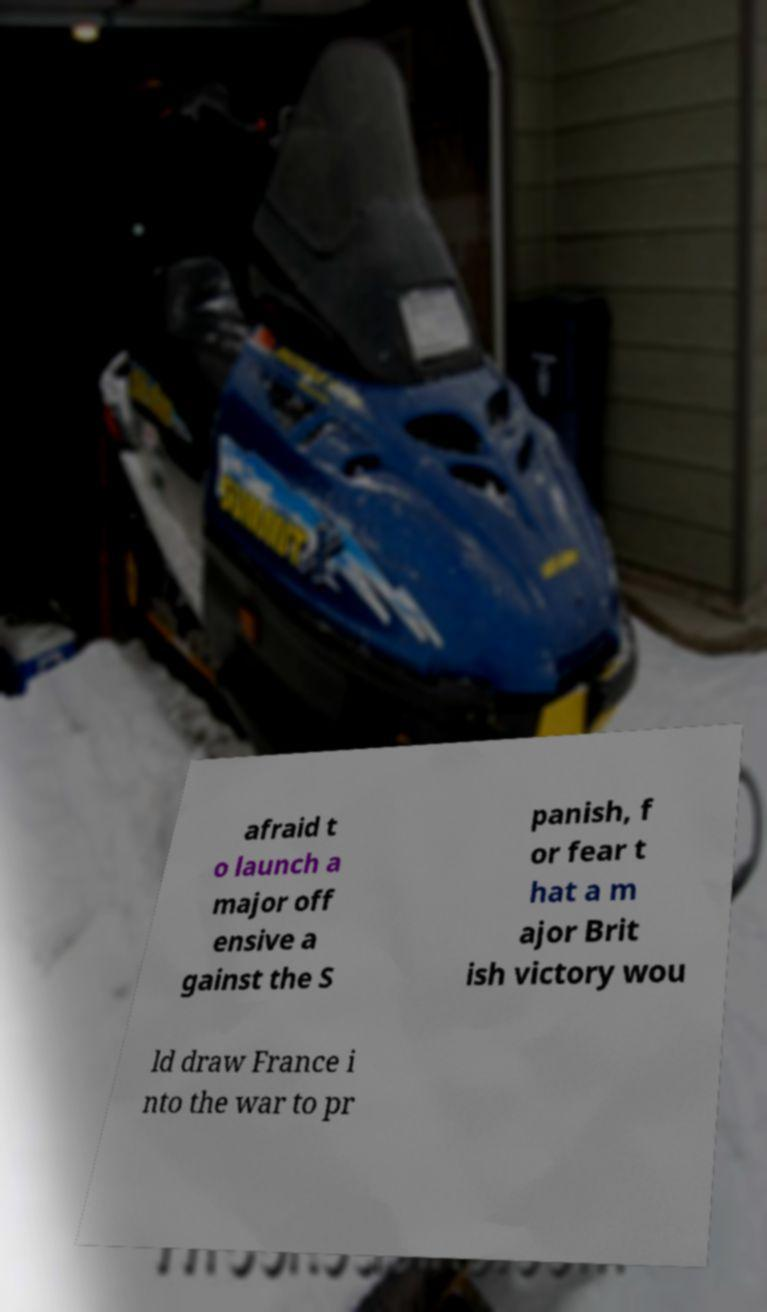Can you read and provide the text displayed in the image?This photo seems to have some interesting text. Can you extract and type it out for me? afraid t o launch a major off ensive a gainst the S panish, f or fear t hat a m ajor Brit ish victory wou ld draw France i nto the war to pr 